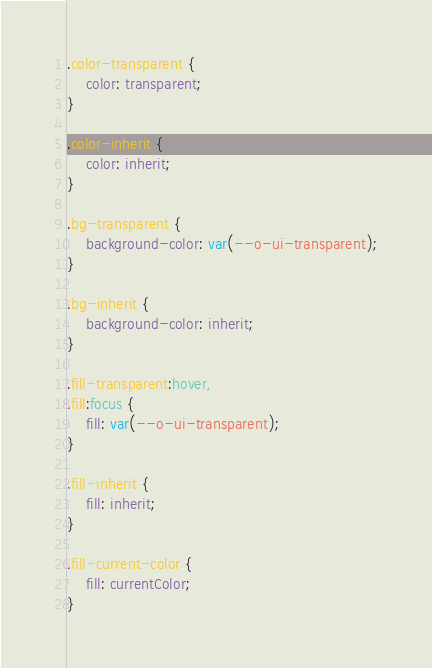<code> <loc_0><loc_0><loc_500><loc_500><_CSS_>.color-transparent {
    color: transparent;
}

.color-inherit {
    color: inherit;
}

.bg-transparent {
    background-color: var(--o-ui-transparent);
}

.bg-inherit {
    background-color: inherit;
}

.fill-transparent:hover,
.fill:focus {
    fill: var(--o-ui-transparent);
}

.fill-inherit {
    fill: inherit;
}

.fill-current-color {
    fill: currentColor;
}
</code> 